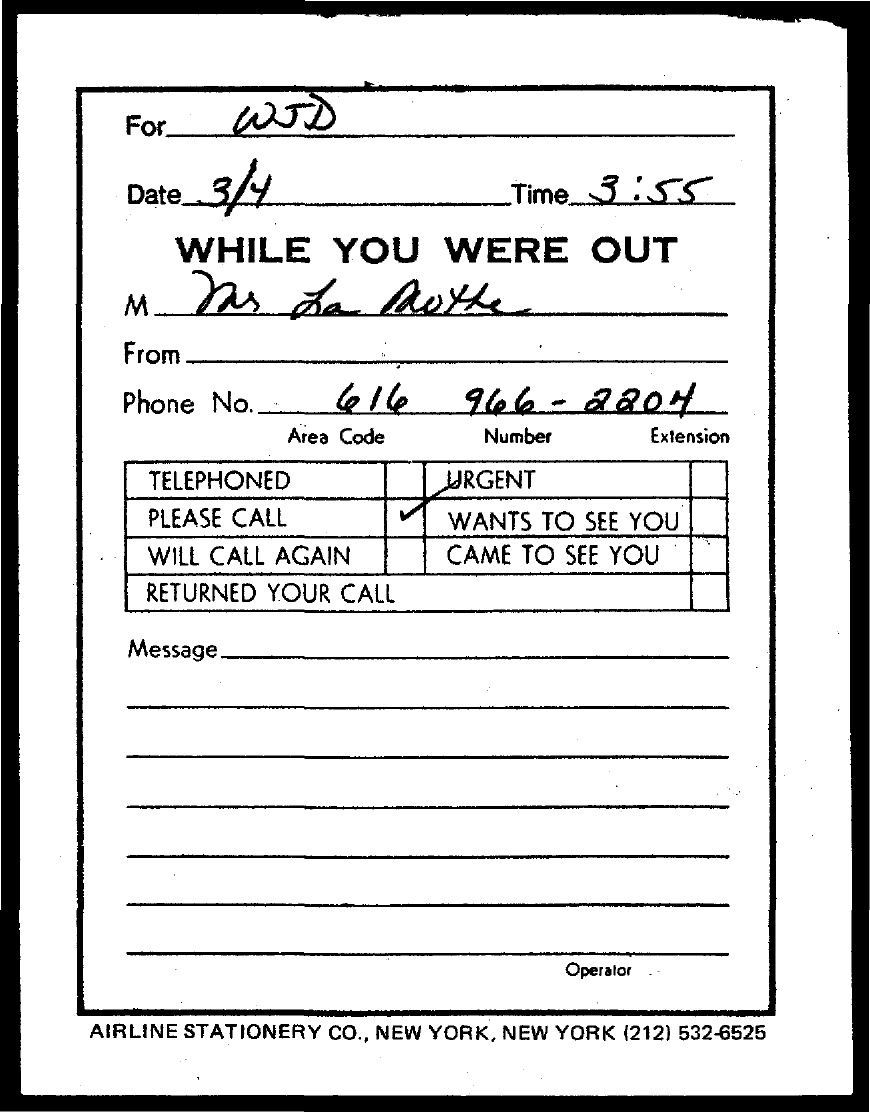Draw attention to some important aspects in this diagram. The time mentioned in the slip is 3 : 55... The date mentioned in this document is 3/4.. 